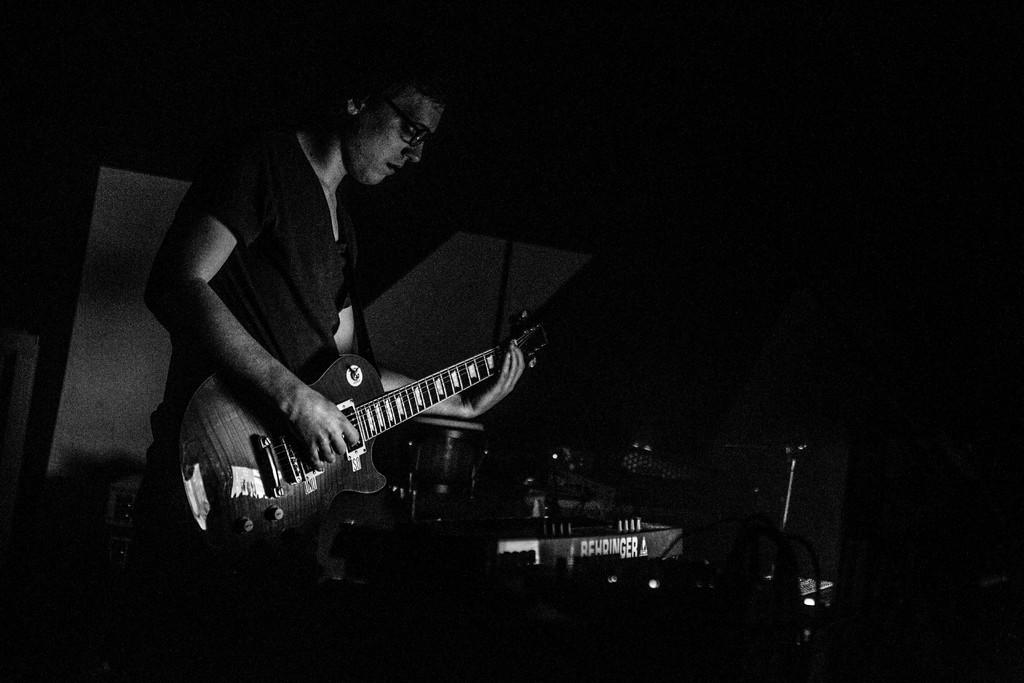What is the man in the image doing? The man is playing a guitar. What can be seen on the man's face in the image? The man is wearing spectacles. What else is present in the image besides the man? There are musical instruments in the image. How many fairies are playing musical instruments with the man in the image? There are no fairies present in the image; it only features a man playing a guitar and other musical instruments. 